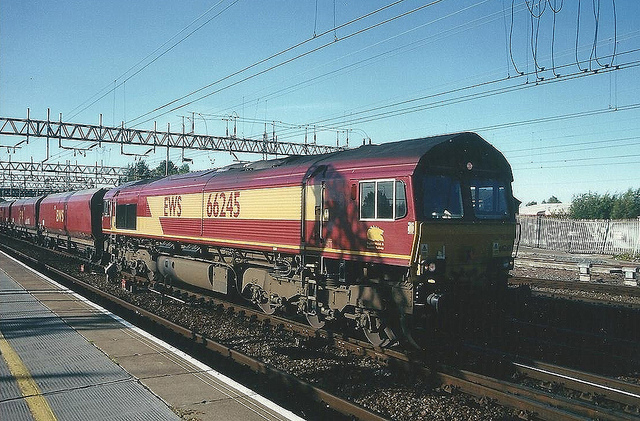Identify the text displayed in this image. EWS 66245 